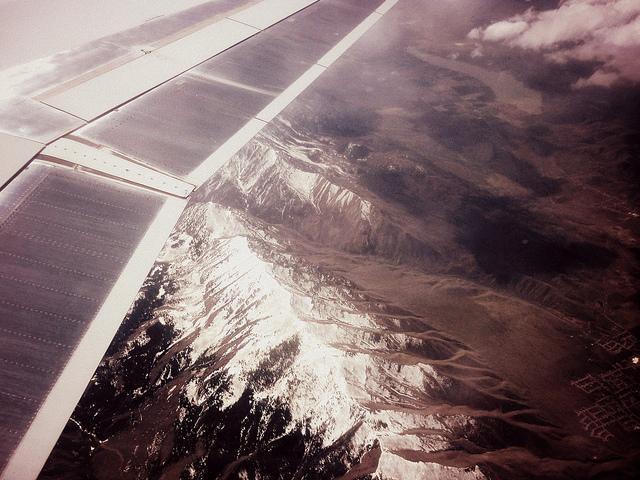How many birds are visible?
Give a very brief answer. 0. 